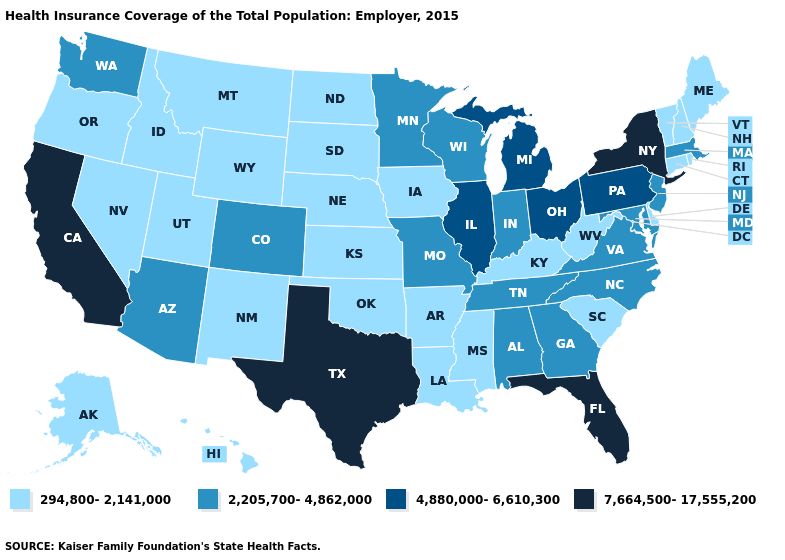What is the value of Alaska?
Keep it brief. 294,800-2,141,000. Name the states that have a value in the range 294,800-2,141,000?
Give a very brief answer. Alaska, Arkansas, Connecticut, Delaware, Hawaii, Idaho, Iowa, Kansas, Kentucky, Louisiana, Maine, Mississippi, Montana, Nebraska, Nevada, New Hampshire, New Mexico, North Dakota, Oklahoma, Oregon, Rhode Island, South Carolina, South Dakota, Utah, Vermont, West Virginia, Wyoming. What is the highest value in the USA?
Write a very short answer. 7,664,500-17,555,200. Which states hav the highest value in the West?
Answer briefly. California. What is the value of California?
Quick response, please. 7,664,500-17,555,200. What is the value of North Carolina?
Short answer required. 2,205,700-4,862,000. Name the states that have a value in the range 4,880,000-6,610,300?
Answer briefly. Illinois, Michigan, Ohio, Pennsylvania. Among the states that border West Virginia , does Ohio have the highest value?
Keep it brief. Yes. Which states have the lowest value in the South?
Be succinct. Arkansas, Delaware, Kentucky, Louisiana, Mississippi, Oklahoma, South Carolina, West Virginia. Among the states that border New York , which have the highest value?
Be succinct. Pennsylvania. What is the lowest value in the MidWest?
Answer briefly. 294,800-2,141,000. What is the lowest value in the West?
Keep it brief. 294,800-2,141,000. Name the states that have a value in the range 294,800-2,141,000?
Answer briefly. Alaska, Arkansas, Connecticut, Delaware, Hawaii, Idaho, Iowa, Kansas, Kentucky, Louisiana, Maine, Mississippi, Montana, Nebraska, Nevada, New Hampshire, New Mexico, North Dakota, Oklahoma, Oregon, Rhode Island, South Carolina, South Dakota, Utah, Vermont, West Virginia, Wyoming. Does Texas have the highest value in the USA?
Be succinct. Yes. Does the map have missing data?
Write a very short answer. No. 